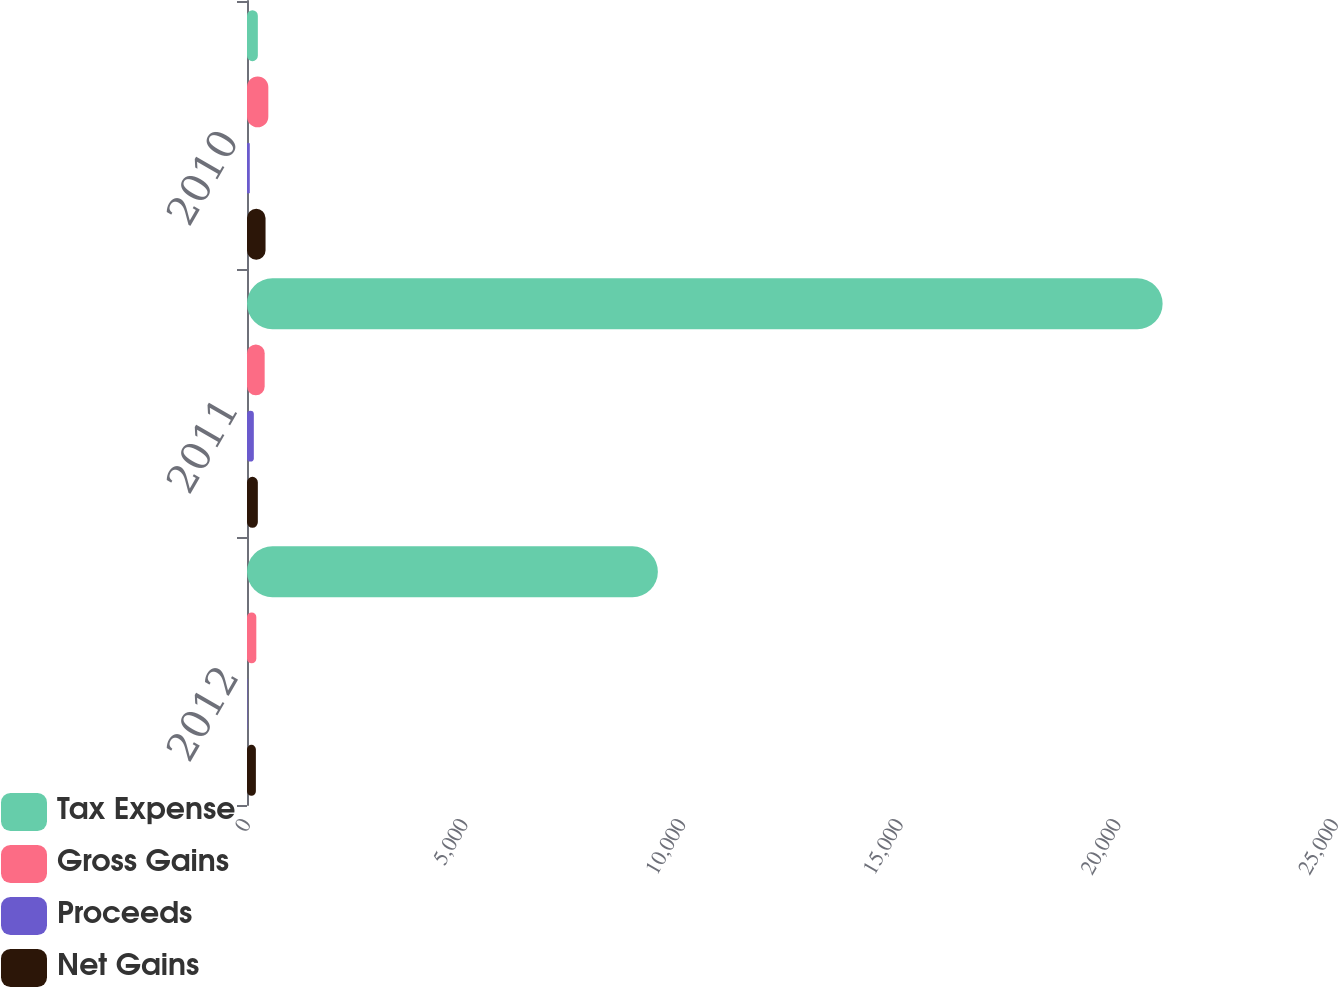Convert chart to OTSL. <chart><loc_0><loc_0><loc_500><loc_500><stacked_bar_chart><ecel><fcel>2012<fcel>2011<fcel>2010<nl><fcel>Tax Expense<fcel>9441<fcel>21039<fcel>249<nl><fcel>Gross Gains<fcel>214<fcel>406<fcel>490<nl><fcel>Proceeds<fcel>10<fcel>157<fcel>64<nl><fcel>Net Gains<fcel>204<fcel>249<fcel>426<nl></chart> 